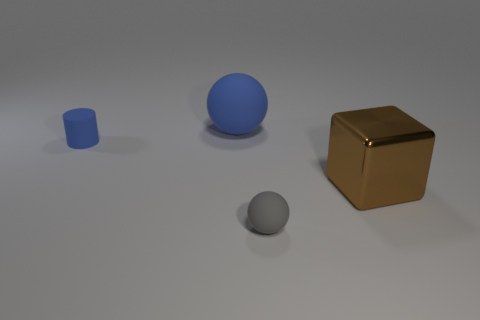Add 3 large brown objects. How many objects exist? 7 Add 3 gray matte things. How many gray matte things exist? 4 Subtract 0 purple balls. How many objects are left? 4 Subtract all green balls. Subtract all gray cylinders. How many balls are left? 2 Subtract all big rubber spheres. Subtract all small blue things. How many objects are left? 2 Add 3 big metallic things. How many big metallic things are left? 4 